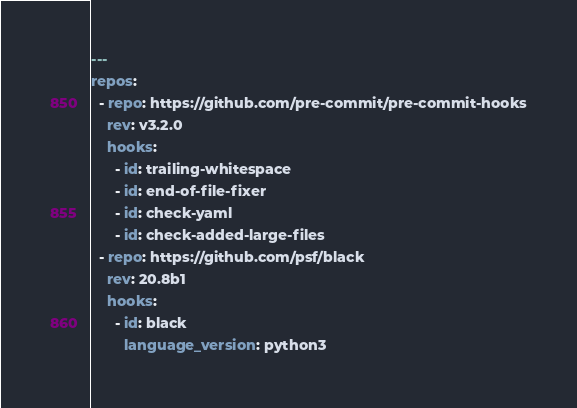<code> <loc_0><loc_0><loc_500><loc_500><_YAML_>---
repos:
  - repo: https://github.com/pre-commit/pre-commit-hooks
    rev: v3.2.0
    hooks:
      - id: trailing-whitespace
      - id: end-of-file-fixer
      - id: check-yaml
      - id: check-added-large-files
  - repo: https://github.com/psf/black
    rev: 20.8b1
    hooks:
      - id: black
        language_version: python3
</code> 